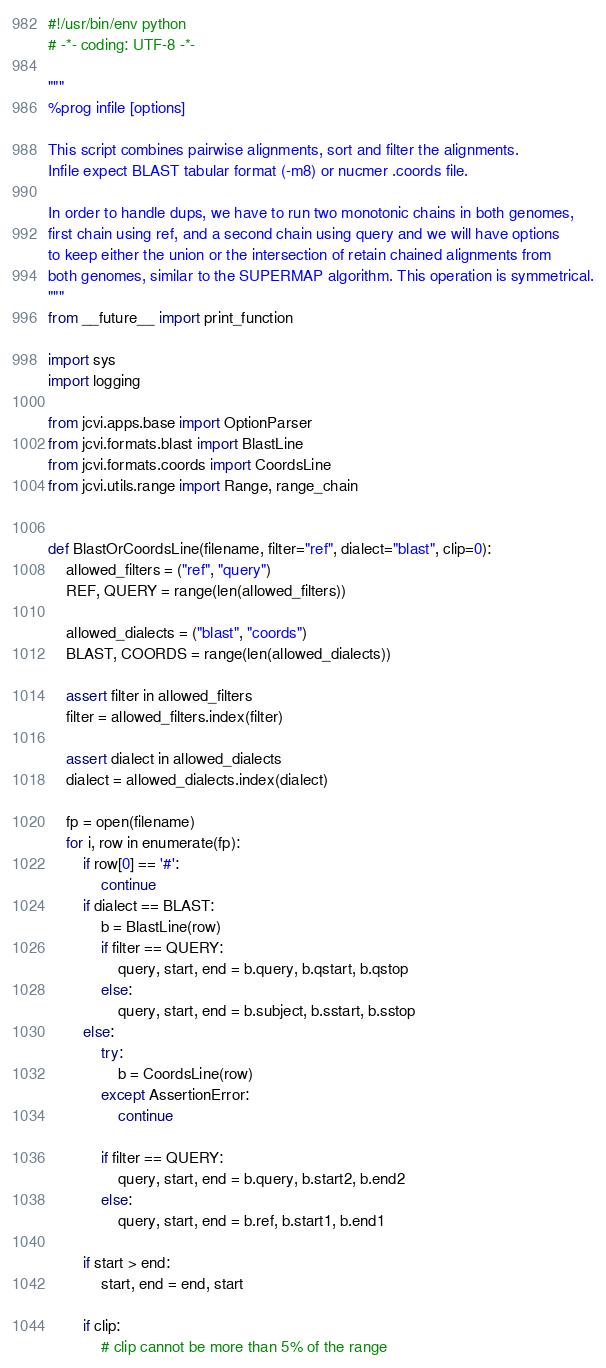<code> <loc_0><loc_0><loc_500><loc_500><_Python_>#!/usr/bin/env python
# -*- coding: UTF-8 -*-

"""
%prog infile [options]

This script combines pairwise alignments, sort and filter the alignments.
Infile expect BLAST tabular format (-m8) or nucmer .coords file.

In order to handle dups, we have to run two monotonic chains in both genomes,
first chain using ref, and a second chain using query and we will have options
to keep either the union or the intersection of retain chained alignments from
both genomes, similar to the SUPERMAP algorithm. This operation is symmetrical.
"""
from __future__ import print_function

import sys
import logging

from jcvi.apps.base import OptionParser
from jcvi.formats.blast import BlastLine
from jcvi.formats.coords import CoordsLine
from jcvi.utils.range import Range, range_chain


def BlastOrCoordsLine(filename, filter="ref", dialect="blast", clip=0):
    allowed_filters = ("ref", "query")
    REF, QUERY = range(len(allowed_filters))

    allowed_dialects = ("blast", "coords")
    BLAST, COORDS = range(len(allowed_dialects))

    assert filter in allowed_filters
    filter = allowed_filters.index(filter)

    assert dialect in allowed_dialects
    dialect = allowed_dialects.index(dialect)

    fp = open(filename)
    for i, row in enumerate(fp):
        if row[0] == '#':
            continue
        if dialect == BLAST:
            b = BlastLine(row)
            if filter == QUERY:
                query, start, end = b.query, b.qstart, b.qstop
            else:
                query, start, end = b.subject, b.sstart, b.sstop
        else:
            try:
                b = CoordsLine(row)
            except AssertionError:
                continue

            if filter == QUERY:
                query, start, end = b.query, b.start2, b.end2
            else:
                query, start, end = b.ref, b.start1, b.end1

        if start > end:
            start, end = end, start

        if clip:
            # clip cannot be more than 5% of the range</code> 